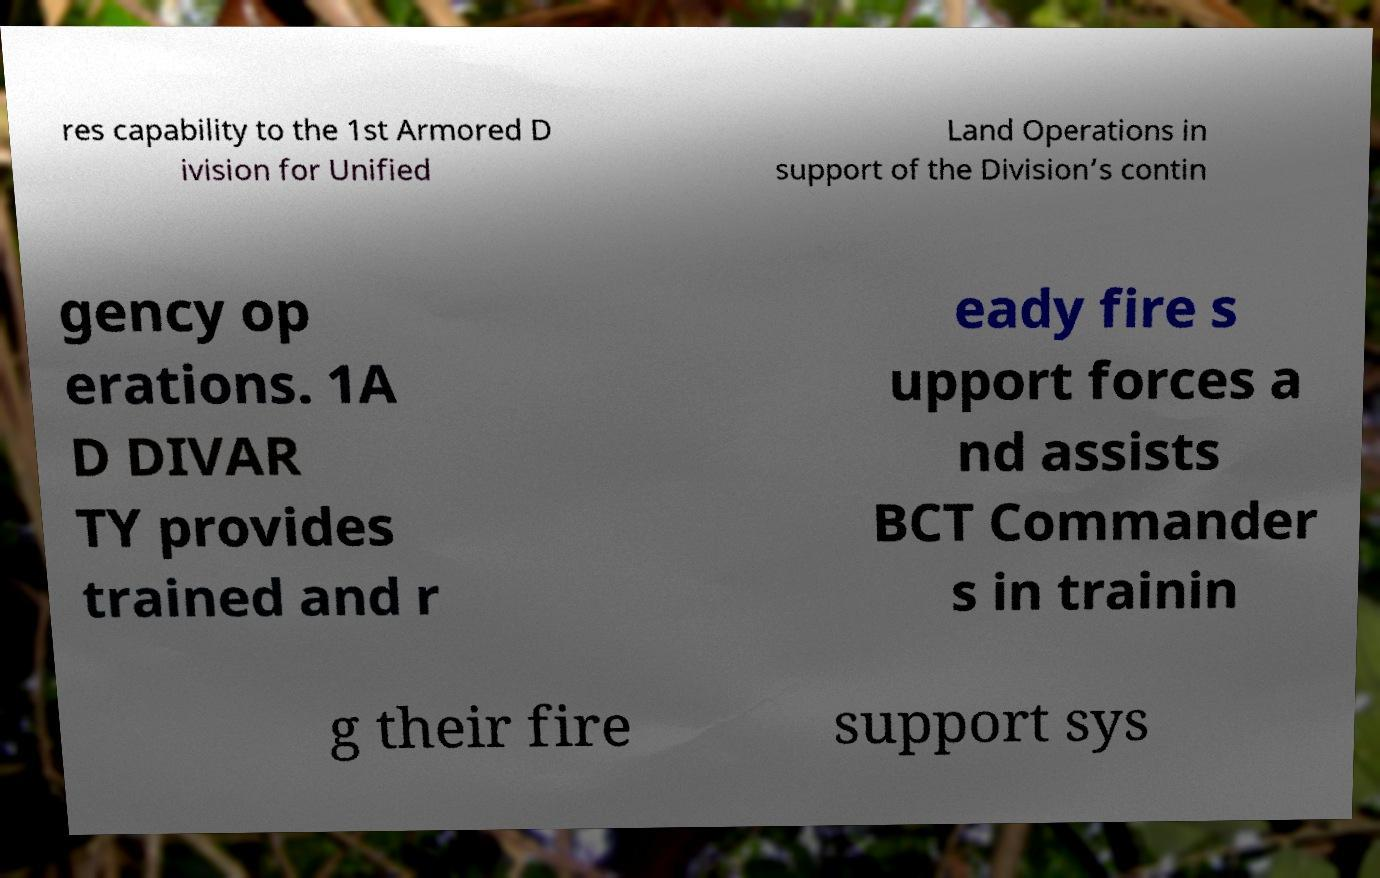There's text embedded in this image that I need extracted. Can you transcribe it verbatim? res capability to the 1st Armored D ivision for Unified Land Operations in support of the Division’s contin gency op erations. 1A D DIVAR TY provides trained and r eady fire s upport forces a nd assists BCT Commander s in trainin g their fire support sys 